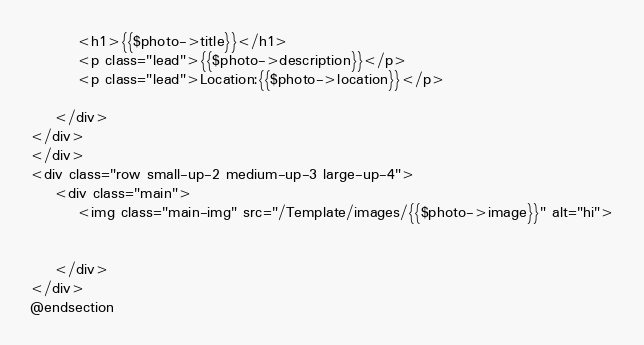<code> <loc_0><loc_0><loc_500><loc_500><_PHP_>

        <h1>{{$photo->title}}</h1>
        <p class="lead">{{$photo->description}}</p>
        <p class="lead">Location:{{$photo->location}}</p>

    </div>
</div>
</div>
<div class="row small-up-2 medium-up-3 large-up-4">
    <div class="main">
        <img class="main-img" src="/Template/images/{{$photo->image}}" alt="hi">
       

    </div>
</div>
@endsection</code> 